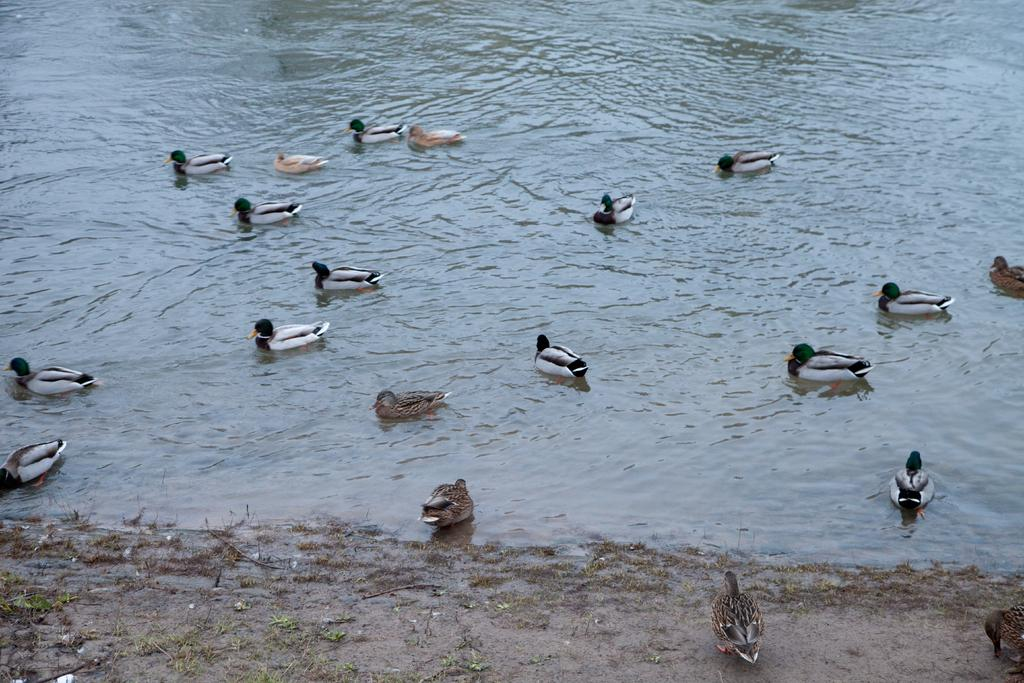What type of terrain is visible at the bottom of the image? There is grass and mud at the bottom of the image. What natural element is present in the middle of the image? There is water in the middle of the image. What type of animals can be seen above the water in the image? There are ducks above the water in the image. How many dimes can be seen floating in the water in the image? There are no dimes present in the image; it features water, ducks, and the terrain. What type of liquid is being pumped in the image? There is no pump or liquid being pumped present in the image. 